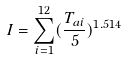Convert formula to latex. <formula><loc_0><loc_0><loc_500><loc_500>I = \sum _ { i = 1 } ^ { 1 2 } ( \frac { T _ { a i } } { 5 } ) ^ { 1 . 5 1 4 }</formula> 